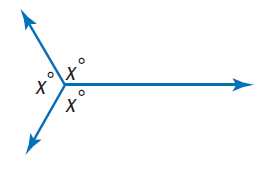Question: Find x.
Choices:
A. 60
B. 120
C. 180
D. 240
Answer with the letter. Answer: B 